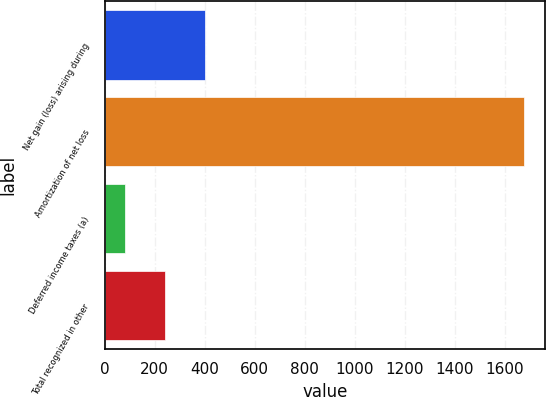Convert chart to OTSL. <chart><loc_0><loc_0><loc_500><loc_500><bar_chart><fcel>Net gain (loss) arising during<fcel>Amortization of net loss<fcel>Deferred income taxes (a)<fcel>Total recognized in other<nl><fcel>401.4<fcel>1679<fcel>82<fcel>241.7<nl></chart> 